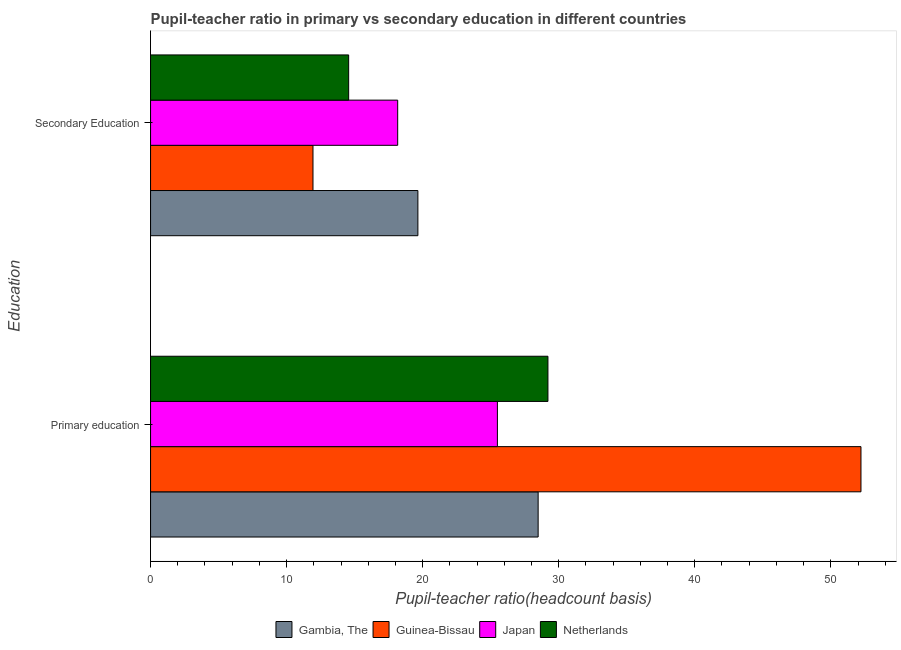How many different coloured bars are there?
Make the answer very short. 4. What is the label of the 2nd group of bars from the top?
Ensure brevity in your answer.  Primary education. What is the pupil-teacher ratio in primary education in Japan?
Ensure brevity in your answer.  25.49. Across all countries, what is the maximum pupil-teacher ratio in primary education?
Give a very brief answer. 52.22. Across all countries, what is the minimum pupil teacher ratio on secondary education?
Your response must be concise. 11.94. In which country was the pupil-teacher ratio in primary education maximum?
Your response must be concise. Guinea-Bissau. In which country was the pupil-teacher ratio in primary education minimum?
Give a very brief answer. Japan. What is the total pupil-teacher ratio in primary education in the graph?
Keep it short and to the point. 135.4. What is the difference between the pupil teacher ratio on secondary education in Japan and that in Netherlands?
Keep it short and to the point. 3.6. What is the difference between the pupil-teacher ratio in primary education in Japan and the pupil teacher ratio on secondary education in Gambia, The?
Your response must be concise. 5.84. What is the average pupil teacher ratio on secondary education per country?
Offer a terse response. 16.08. What is the difference between the pupil teacher ratio on secondary education and pupil-teacher ratio in primary education in Guinea-Bissau?
Your answer should be compact. -40.28. In how many countries, is the pupil teacher ratio on secondary education greater than 38 ?
Give a very brief answer. 0. What is the ratio of the pupil-teacher ratio in primary education in Guinea-Bissau to that in Netherlands?
Ensure brevity in your answer.  1.79. Is the pupil-teacher ratio in primary education in Gambia, The less than that in Guinea-Bissau?
Make the answer very short. Yes. What does the 2nd bar from the bottom in Primary education represents?
Your answer should be very brief. Guinea-Bissau. How many bars are there?
Ensure brevity in your answer.  8. Are all the bars in the graph horizontal?
Offer a very short reply. Yes. How many countries are there in the graph?
Keep it short and to the point. 4. Are the values on the major ticks of X-axis written in scientific E-notation?
Your response must be concise. No. Where does the legend appear in the graph?
Ensure brevity in your answer.  Bottom center. How many legend labels are there?
Make the answer very short. 4. How are the legend labels stacked?
Offer a very short reply. Horizontal. What is the title of the graph?
Keep it short and to the point. Pupil-teacher ratio in primary vs secondary education in different countries. What is the label or title of the X-axis?
Your answer should be very brief. Pupil-teacher ratio(headcount basis). What is the label or title of the Y-axis?
Provide a short and direct response. Education. What is the Pupil-teacher ratio(headcount basis) in Gambia, The in Primary education?
Ensure brevity in your answer.  28.49. What is the Pupil-teacher ratio(headcount basis) in Guinea-Bissau in Primary education?
Provide a short and direct response. 52.22. What is the Pupil-teacher ratio(headcount basis) of Japan in Primary education?
Provide a short and direct response. 25.49. What is the Pupil-teacher ratio(headcount basis) in Netherlands in Primary education?
Make the answer very short. 29.21. What is the Pupil-teacher ratio(headcount basis) of Gambia, The in Secondary Education?
Provide a short and direct response. 19.65. What is the Pupil-teacher ratio(headcount basis) of Guinea-Bissau in Secondary Education?
Provide a succinct answer. 11.94. What is the Pupil-teacher ratio(headcount basis) in Japan in Secondary Education?
Provide a short and direct response. 18.16. What is the Pupil-teacher ratio(headcount basis) of Netherlands in Secondary Education?
Provide a short and direct response. 14.56. Across all Education, what is the maximum Pupil-teacher ratio(headcount basis) in Gambia, The?
Your answer should be compact. 28.49. Across all Education, what is the maximum Pupil-teacher ratio(headcount basis) in Guinea-Bissau?
Provide a succinct answer. 52.22. Across all Education, what is the maximum Pupil-teacher ratio(headcount basis) in Japan?
Give a very brief answer. 25.49. Across all Education, what is the maximum Pupil-teacher ratio(headcount basis) in Netherlands?
Offer a terse response. 29.21. Across all Education, what is the minimum Pupil-teacher ratio(headcount basis) in Gambia, The?
Your answer should be compact. 19.65. Across all Education, what is the minimum Pupil-teacher ratio(headcount basis) of Guinea-Bissau?
Offer a terse response. 11.94. Across all Education, what is the minimum Pupil-teacher ratio(headcount basis) in Japan?
Your answer should be compact. 18.16. Across all Education, what is the minimum Pupil-teacher ratio(headcount basis) of Netherlands?
Give a very brief answer. 14.56. What is the total Pupil-teacher ratio(headcount basis) in Gambia, The in the graph?
Offer a terse response. 48.14. What is the total Pupil-teacher ratio(headcount basis) in Guinea-Bissau in the graph?
Your answer should be very brief. 64.15. What is the total Pupil-teacher ratio(headcount basis) in Japan in the graph?
Give a very brief answer. 43.66. What is the total Pupil-teacher ratio(headcount basis) in Netherlands in the graph?
Ensure brevity in your answer.  43.77. What is the difference between the Pupil-teacher ratio(headcount basis) in Gambia, The in Primary education and that in Secondary Education?
Offer a very short reply. 8.84. What is the difference between the Pupil-teacher ratio(headcount basis) of Guinea-Bissau in Primary education and that in Secondary Education?
Provide a succinct answer. 40.28. What is the difference between the Pupil-teacher ratio(headcount basis) of Japan in Primary education and that in Secondary Education?
Offer a very short reply. 7.33. What is the difference between the Pupil-teacher ratio(headcount basis) in Netherlands in Primary education and that in Secondary Education?
Your answer should be compact. 14.65. What is the difference between the Pupil-teacher ratio(headcount basis) in Gambia, The in Primary education and the Pupil-teacher ratio(headcount basis) in Guinea-Bissau in Secondary Education?
Offer a very short reply. 16.55. What is the difference between the Pupil-teacher ratio(headcount basis) in Gambia, The in Primary education and the Pupil-teacher ratio(headcount basis) in Japan in Secondary Education?
Offer a terse response. 10.32. What is the difference between the Pupil-teacher ratio(headcount basis) of Gambia, The in Primary education and the Pupil-teacher ratio(headcount basis) of Netherlands in Secondary Education?
Offer a terse response. 13.93. What is the difference between the Pupil-teacher ratio(headcount basis) of Guinea-Bissau in Primary education and the Pupil-teacher ratio(headcount basis) of Japan in Secondary Education?
Give a very brief answer. 34.05. What is the difference between the Pupil-teacher ratio(headcount basis) of Guinea-Bissau in Primary education and the Pupil-teacher ratio(headcount basis) of Netherlands in Secondary Education?
Provide a short and direct response. 37.66. What is the difference between the Pupil-teacher ratio(headcount basis) of Japan in Primary education and the Pupil-teacher ratio(headcount basis) of Netherlands in Secondary Education?
Offer a very short reply. 10.93. What is the average Pupil-teacher ratio(headcount basis) of Gambia, The per Education?
Offer a very short reply. 24.07. What is the average Pupil-teacher ratio(headcount basis) of Guinea-Bissau per Education?
Your response must be concise. 32.08. What is the average Pupil-teacher ratio(headcount basis) of Japan per Education?
Provide a short and direct response. 21.83. What is the average Pupil-teacher ratio(headcount basis) in Netherlands per Education?
Make the answer very short. 21.88. What is the difference between the Pupil-teacher ratio(headcount basis) of Gambia, The and Pupil-teacher ratio(headcount basis) of Guinea-Bissau in Primary education?
Your answer should be very brief. -23.73. What is the difference between the Pupil-teacher ratio(headcount basis) in Gambia, The and Pupil-teacher ratio(headcount basis) in Japan in Primary education?
Offer a terse response. 2.99. What is the difference between the Pupil-teacher ratio(headcount basis) of Gambia, The and Pupil-teacher ratio(headcount basis) of Netherlands in Primary education?
Provide a succinct answer. -0.72. What is the difference between the Pupil-teacher ratio(headcount basis) in Guinea-Bissau and Pupil-teacher ratio(headcount basis) in Japan in Primary education?
Keep it short and to the point. 26.72. What is the difference between the Pupil-teacher ratio(headcount basis) of Guinea-Bissau and Pupil-teacher ratio(headcount basis) of Netherlands in Primary education?
Make the answer very short. 23.01. What is the difference between the Pupil-teacher ratio(headcount basis) of Japan and Pupil-teacher ratio(headcount basis) of Netherlands in Primary education?
Give a very brief answer. -3.71. What is the difference between the Pupil-teacher ratio(headcount basis) of Gambia, The and Pupil-teacher ratio(headcount basis) of Guinea-Bissau in Secondary Education?
Provide a short and direct response. 7.71. What is the difference between the Pupil-teacher ratio(headcount basis) of Gambia, The and Pupil-teacher ratio(headcount basis) of Japan in Secondary Education?
Your answer should be very brief. 1.48. What is the difference between the Pupil-teacher ratio(headcount basis) in Gambia, The and Pupil-teacher ratio(headcount basis) in Netherlands in Secondary Education?
Your answer should be very brief. 5.09. What is the difference between the Pupil-teacher ratio(headcount basis) of Guinea-Bissau and Pupil-teacher ratio(headcount basis) of Japan in Secondary Education?
Make the answer very short. -6.23. What is the difference between the Pupil-teacher ratio(headcount basis) of Guinea-Bissau and Pupil-teacher ratio(headcount basis) of Netherlands in Secondary Education?
Provide a succinct answer. -2.62. What is the difference between the Pupil-teacher ratio(headcount basis) in Japan and Pupil-teacher ratio(headcount basis) in Netherlands in Secondary Education?
Make the answer very short. 3.6. What is the ratio of the Pupil-teacher ratio(headcount basis) in Gambia, The in Primary education to that in Secondary Education?
Your answer should be very brief. 1.45. What is the ratio of the Pupil-teacher ratio(headcount basis) of Guinea-Bissau in Primary education to that in Secondary Education?
Your answer should be very brief. 4.37. What is the ratio of the Pupil-teacher ratio(headcount basis) of Japan in Primary education to that in Secondary Education?
Provide a succinct answer. 1.4. What is the ratio of the Pupil-teacher ratio(headcount basis) of Netherlands in Primary education to that in Secondary Education?
Provide a succinct answer. 2.01. What is the difference between the highest and the second highest Pupil-teacher ratio(headcount basis) in Gambia, The?
Offer a very short reply. 8.84. What is the difference between the highest and the second highest Pupil-teacher ratio(headcount basis) of Guinea-Bissau?
Ensure brevity in your answer.  40.28. What is the difference between the highest and the second highest Pupil-teacher ratio(headcount basis) in Japan?
Provide a succinct answer. 7.33. What is the difference between the highest and the second highest Pupil-teacher ratio(headcount basis) of Netherlands?
Your response must be concise. 14.65. What is the difference between the highest and the lowest Pupil-teacher ratio(headcount basis) of Gambia, The?
Your response must be concise. 8.84. What is the difference between the highest and the lowest Pupil-teacher ratio(headcount basis) of Guinea-Bissau?
Ensure brevity in your answer.  40.28. What is the difference between the highest and the lowest Pupil-teacher ratio(headcount basis) of Japan?
Your answer should be very brief. 7.33. What is the difference between the highest and the lowest Pupil-teacher ratio(headcount basis) in Netherlands?
Provide a succinct answer. 14.65. 